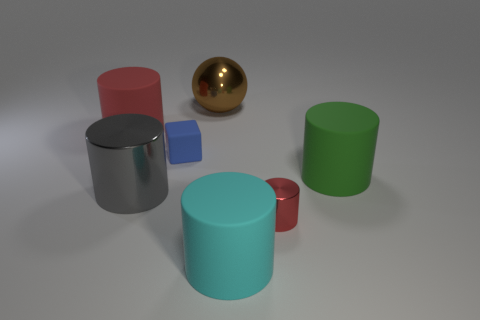Add 3 matte cylinders. How many objects exist? 10 Subtract all big green matte cylinders. How many cylinders are left? 4 Subtract all cyan cylinders. How many cylinders are left? 4 Subtract all brown blocks. How many red cylinders are left? 2 Subtract all balls. How many objects are left? 6 Subtract 5 cylinders. How many cylinders are left? 0 Subtract all red cylinders. Subtract all green spheres. How many cylinders are left? 3 Subtract all red cylinders. Subtract all red metallic cylinders. How many objects are left? 4 Add 2 red matte cylinders. How many red matte cylinders are left? 3 Add 3 big gray cylinders. How many big gray cylinders exist? 4 